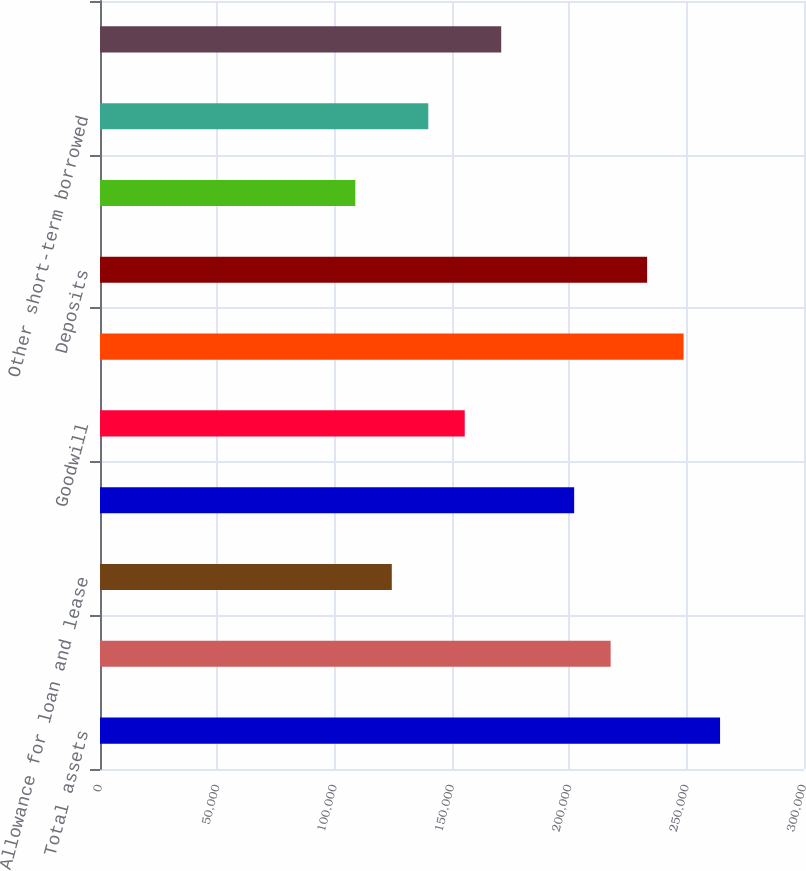<chart> <loc_0><loc_0><loc_500><loc_500><bar_chart><fcel>Total assets<fcel>Loans and leases (10)<fcel>Allowance for loan and lease<fcel>Total securities<fcel>Goodwill<fcel>Total liabilities<fcel>Deposits<fcel>Federal funds purchased and<fcel>Other short-term borrowed<fcel>Long-term borrowed funds<nl><fcel>264232<fcel>217603<fcel>124345<fcel>202060<fcel>155431<fcel>248689<fcel>233146<fcel>108802<fcel>139888<fcel>170974<nl></chart> 